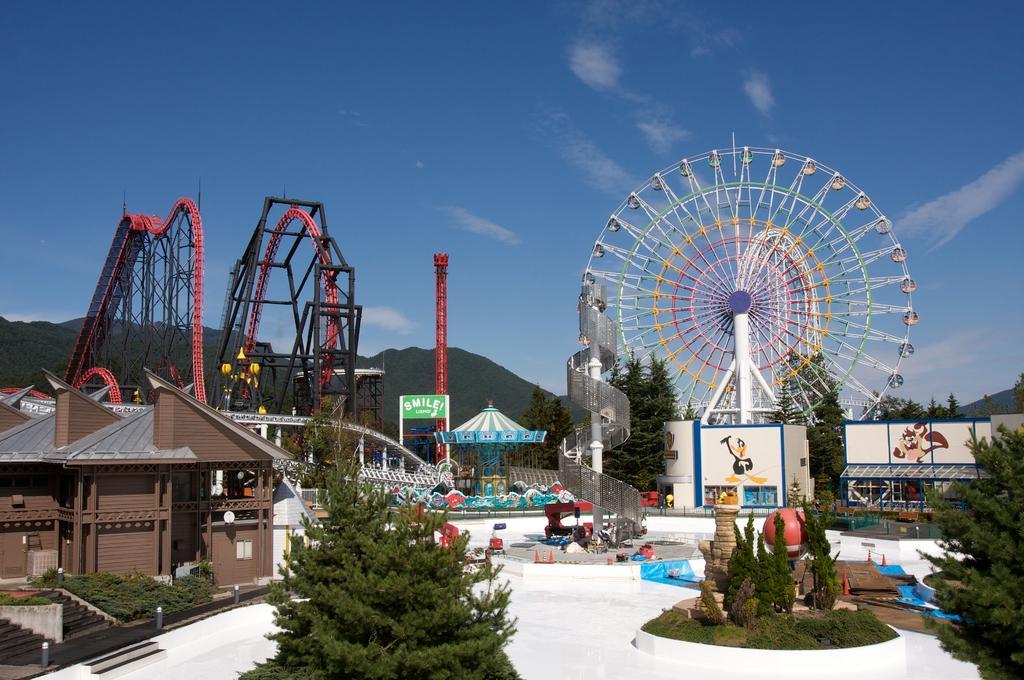Describe this image in one or two sentences. In this image I can see the plants. To the left I can see the house and the stairs. In the background I can see many rides and also boards. I can see the mountains, trees, clouds and the blue sky. 